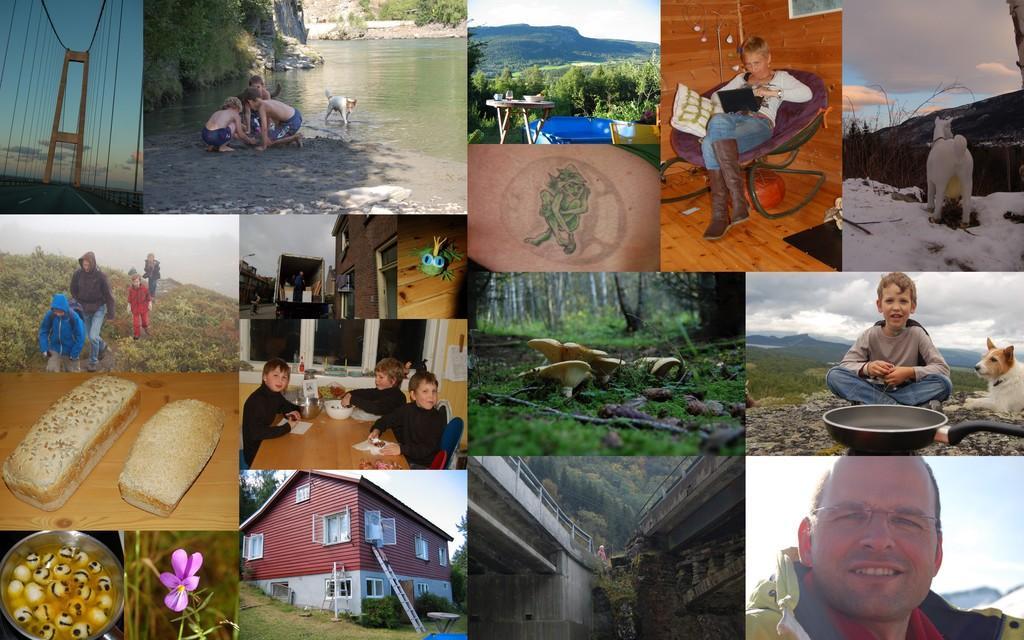Describe this image in one or two sentences. It is the image in which there is a collage of so many images. In the middle there is a house. On the left side there is a bridge. Beside bridge there is a photo in which there are kids playing on the sand. On the right side there is a man. In front of him there is a pan. 